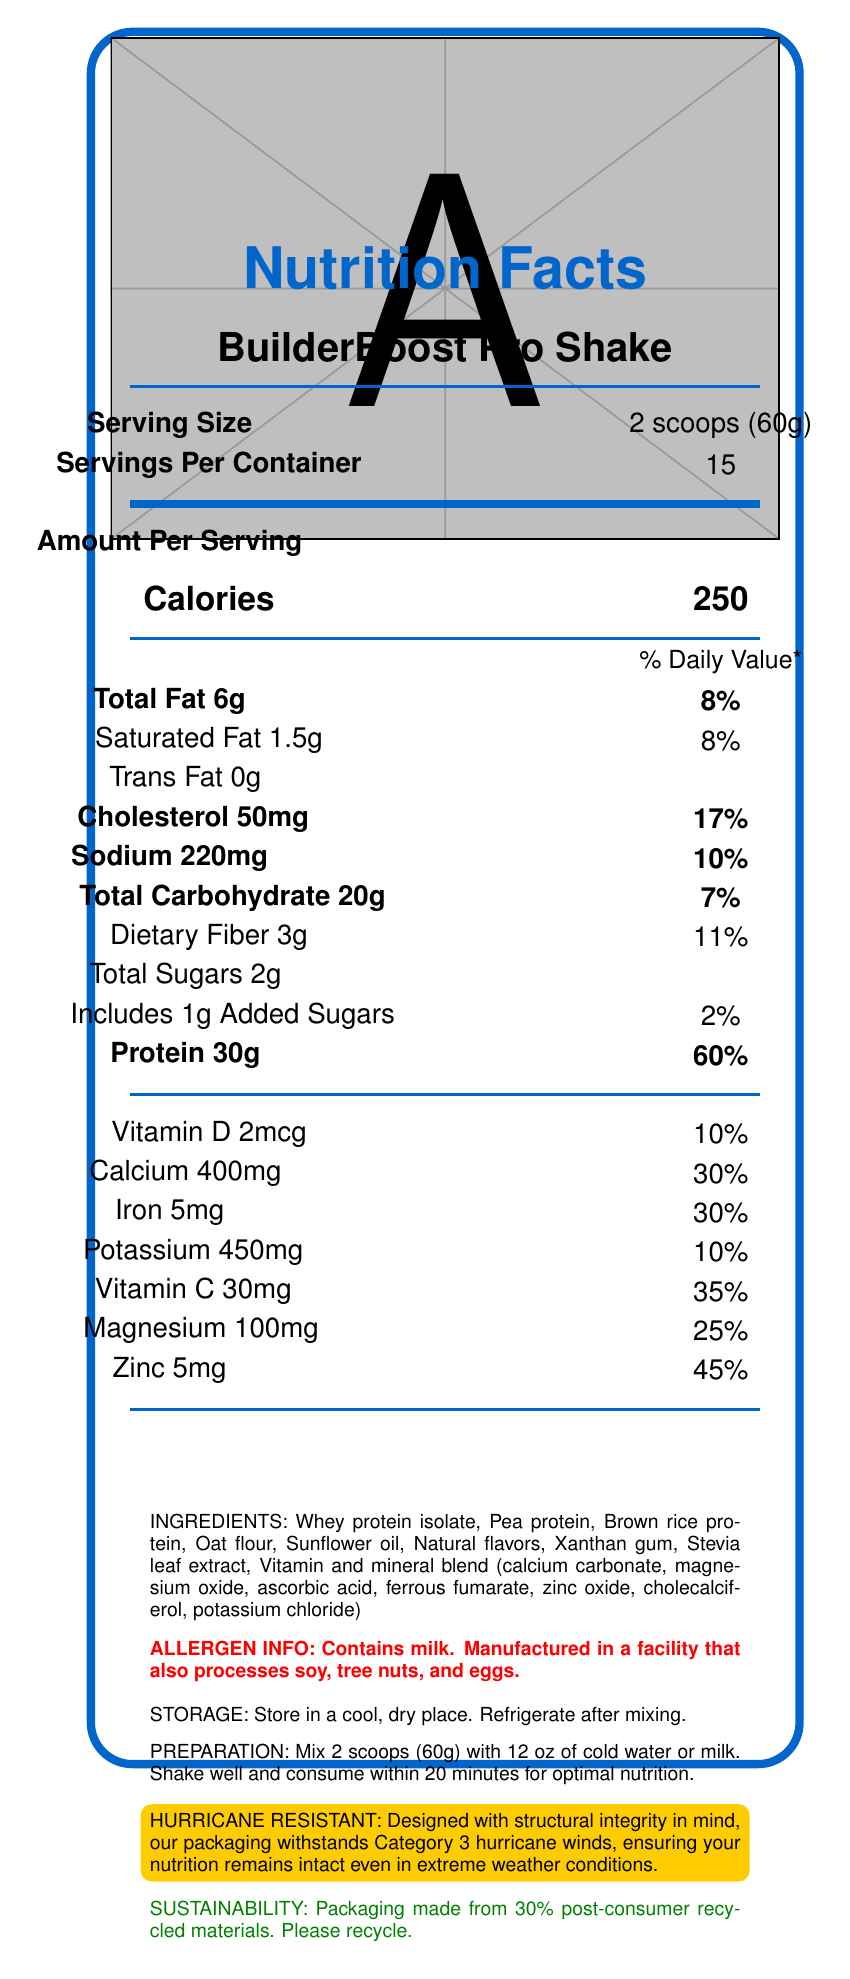what is the serving size of BuilderBoost Pro Shake? The serving size is mentioned in the "Serving Size" section of the Nutrition Facts label.
Answer: 2 scoops (60g) how many calories are in one serving of BuilderBoost Pro Shake? The number of calories is listed under "Amount Per Serving" in the Calories section.
Answer: 250 how much protein does one serving of this shake provide? The protein content is mentioned under "Amount Per Serving" and specifically labeled as "Protein."
Answer: 30g what percentage of the daily value of sodium does one serving of this shake provide? The daily value percentage for sodium is listed alongside its amount in milligrams under "Amount Per Serving."
Answer: 10% how many servings are there in one container of BuilderBoost Pro Shake? The number of servings per container is stated next to "Servings Per Container."
Answer: 15 which of the following vitamins is not listed under the nutrients section of BuilderBoost Pro Shake? A. Vitamin B12 B. Vitamin D C. Vitamin C D. Magnesium Vitamin B12 is not mentioned in the nutrients section, whereas Vitamin D, Vitamin C, and Magnesium are listed.
Answer: A what is the daily value percentage of calcium in one serving? A. 10% B. 25% C. 30% D. 35% Calcium's daily value percentage is labeled as 30%, which is directly stated in the nutrients section.
Answer: C does BuilderBoost Pro Shake contain any dietary fiber? It contains 3g of dietary fiber as mentioned under "Total Carbohydrate."
Answer: Yes should the prepared shake be refrigerated if not consumed immediately? The storage instructions mention that the product should be refrigerated after mixing.
Answer: Yes describe the main highlights of the Nutrition Facts label for BuilderBoost Pro Shake. The document provides detailed nutritional information about BuilderBoost Pro Shake, specifying serving size, calorie content, macronutrient breakdown, and various vitamins and minerals. It also highlights allergen warnings, preparation, and storage instructions, along with information on packaging sustainability and its unique hurricane-resistant design.
Answer: The Nutrition Facts label for BuilderBoost Pro Shake highlights the product details, including a serving size of 2 scoops (60g), 250 calories per serving, 30g of protein, and a blend of vitamins and minerals. It provides information on fat, carbohydrates, protein, and key vitamins and minerals like Vitamin D, Calcium, Iron, and Magnesium. It also includes allergen information, storage, and preparation instructions, along with the sustainability details and a unique feature of hurricane-resistant packaging. how many grams of added sugars are in one serving? The amount of added sugars per serving is specifically mentioned in the "Total Sugars" section as 1g.
Answer: 1g is this shake suitable for someone with soy allergies? The allergen information states that it is manufactured in a facility that also processes soy, which indicates potential cross-contamination.
Answer: No what material is used for the packaging of the BuilderBoost Pro Shake? The sustainability info mentions that the packaging is made from 30% post-consumer recycled materials.
Answer: 30% post-consumer recycled materials can the nutritional value of Vitamin A be found in this document? The document does not provide any information about the Vitamin A content or its daily value percentage.
Answer: No how many grams of total carbohydrates are in one serving? The total carbohydrate content per serving is listed in the "Total Carbohydrate" section as 20g.
Answer: 20g what is the cholesterol content in one serving of BuilderBoost Pro Shake? The cholesterol content is listed under "Amount Per Serving" and specifically labeled as "Cholesterol."
Answer: 50mg 